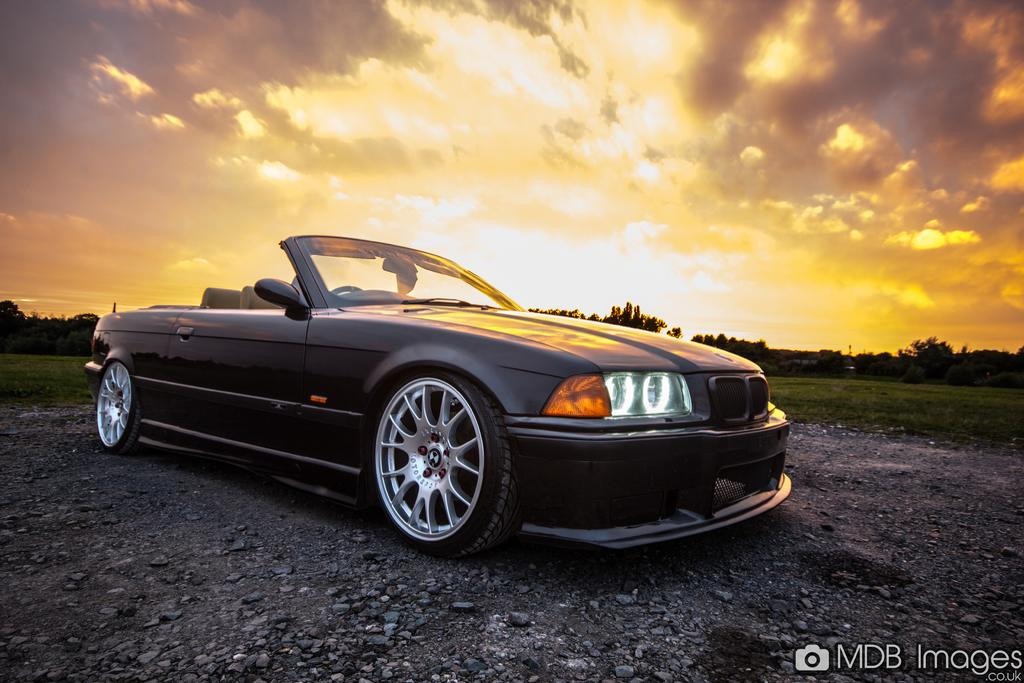What is the main subject in the center of the image? There is a car in the center of the image. How is the car positioned in the image? The car is placed on the ground. What type of terrain can be seen in the image? There are stones and grass visible in the image. What type of vegetation is present in the image? There is a group of trees in the image. What is visible in the sky in the image? The sky is visible in the image and appears cloudy. What type of shirt is the beast wearing in the image? There is no beast or shirt present in the image. 